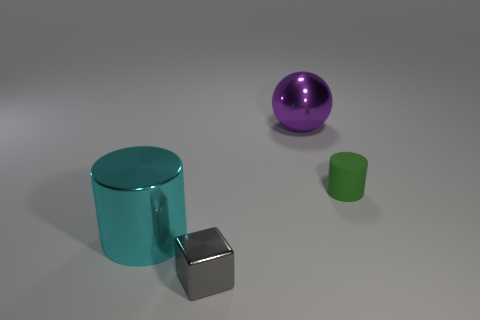How many other things are there of the same shape as the small gray shiny object?
Provide a short and direct response. 0. Is the number of large cyan cylinders in front of the big cyan cylinder less than the number of cyan things?
Provide a succinct answer. Yes. There is a cylinder that is right of the cyan metal cylinder; what is its material?
Give a very brief answer. Rubber. How many other objects are the same size as the green cylinder?
Your answer should be compact. 1. Are there fewer small gray blocks than blue matte balls?
Your answer should be compact. No. What shape is the big cyan metal object?
Your answer should be compact. Cylinder. There is a tiny object that is in front of the small matte cylinder; is its color the same as the small matte cylinder?
Your answer should be compact. No. What is the shape of the metallic thing that is both behind the gray metal object and right of the cyan object?
Your response must be concise. Sphere. There is a large shiny object on the right side of the large cyan metal cylinder; what is its color?
Make the answer very short. Purple. Is there anything else of the same color as the metal cylinder?
Provide a succinct answer. No. 